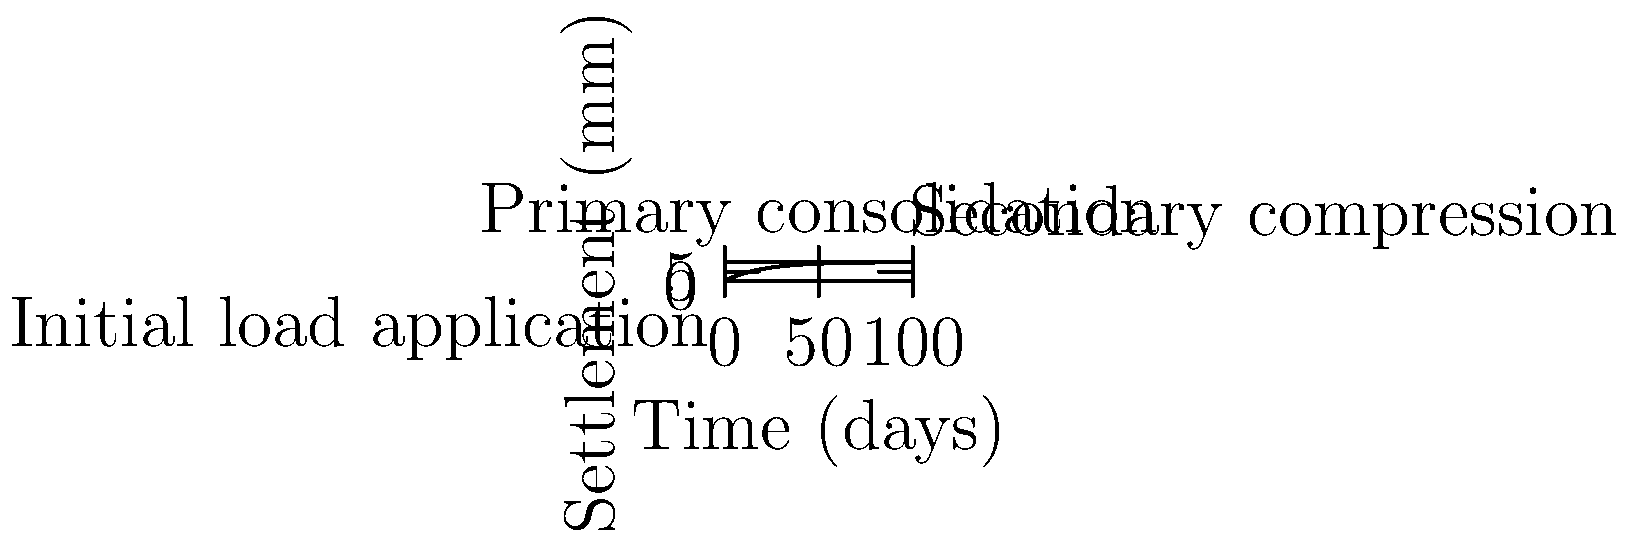Given the soil consolidation curve shown, which represents settlement over time under a constant foundation load, estimate the time (in days) required to achieve 90% of the total expected settlement. How might this temporal progression relate to the concept of strange attractors in chaos theory applied to neural networks? To solve this problem and relate it to chaos theory in neural networks, let's follow these steps:

1) The consolidation curve follows the equation:
   $$S(t) = S_f(1-e^{-ct})$$
   where $S(t)$ is settlement at time $t$, $S_f$ is final settlement, and $c$ is a consolidation coefficient.

2) From the graph, we can estimate $S_f \approx 10$ mm.

3) For 90% consolidation, we need to find $t$ when $S(t) = 0.9S_f = 9$ mm.

4) Substituting into the equation:
   $$9 = 10(1-e^{-ct})$$

5) Solving for $t$:
   $$0.9 = 1-e^{-ct}$$
   $$e^{-ct} = 0.1$$
   $$-ct = ln(0.1)$$
   $$t = -\frac{ln(0.1)}{c}$$

6) From the graph, we can estimate $c \approx 0.05$ day^(-1).

7) Therefore:
   $$t = -\frac{ln(0.1)}{0.05} \approx 46$$ days

8) Relating to chaos theory and neural networks:
   - The consolidation curve represents a system approaching equilibrium, similar to how neural networks converge during training.
   - In chaos theory, strange attractors represent complex, sometimes fractal structures in phase space towards which dynamic systems evolve.
   - The consolidation curve could be seen as a simple attractor, while neural networks might exhibit more complex, potentially chaotic attractors during learning processes.
   - The temporal progression in both soil consolidation and neural network training involves non-linear dynamics, a key aspect of chaos theory.
   - Understanding these temporal dynamics could provide insights into optimizing neural network training schedules and predicting long-term behavior of both geotechnical structures and brain function.
Answer: Approximately 46 days; both processes involve non-linear temporal dynamics approaching equilibrium states or attractors. 